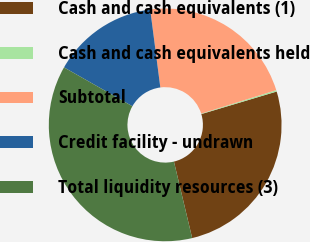<chart> <loc_0><loc_0><loc_500><loc_500><pie_chart><fcel>Cash and cash equivalents (1)<fcel>Cash and cash equivalents held<fcel>Subtotal<fcel>Credit facility - undrawn<fcel>Total liquidity resources (3)<nl><fcel>25.9%<fcel>0.2%<fcel>22.23%<fcel>14.72%<fcel>36.95%<nl></chart> 